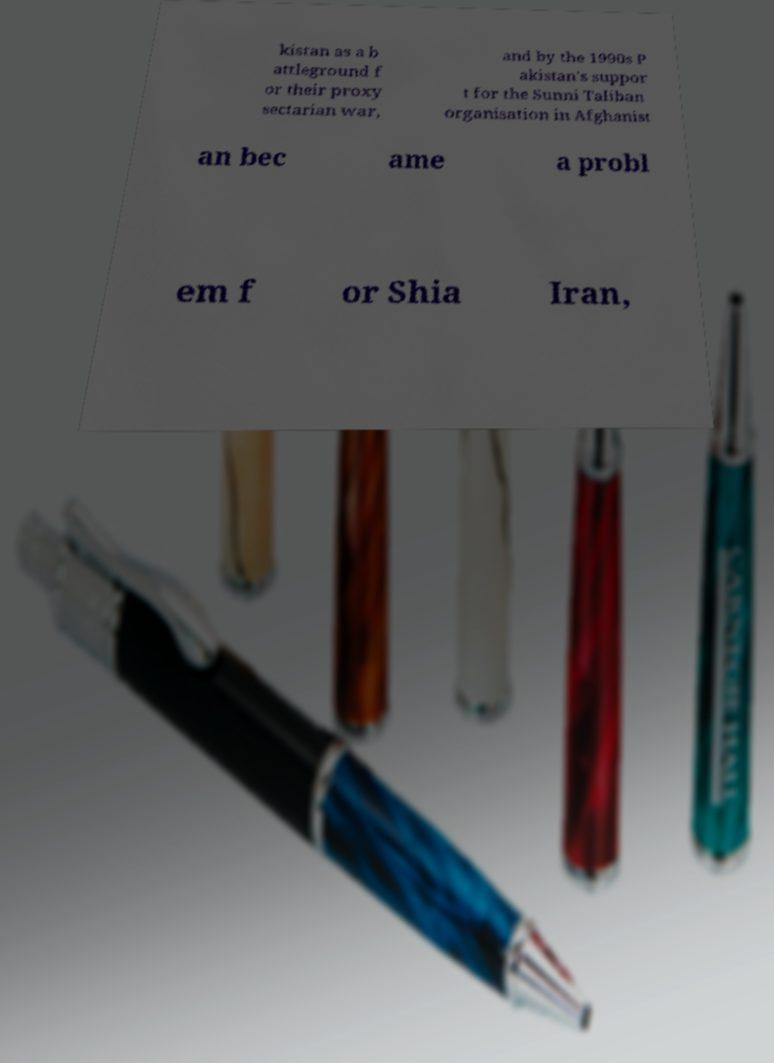Could you assist in decoding the text presented in this image and type it out clearly? kistan as a b attleground f or their proxy sectarian war, and by the 1990s P akistan's suppor t for the Sunni Taliban organisation in Afghanist an bec ame a probl em f or Shia Iran, 